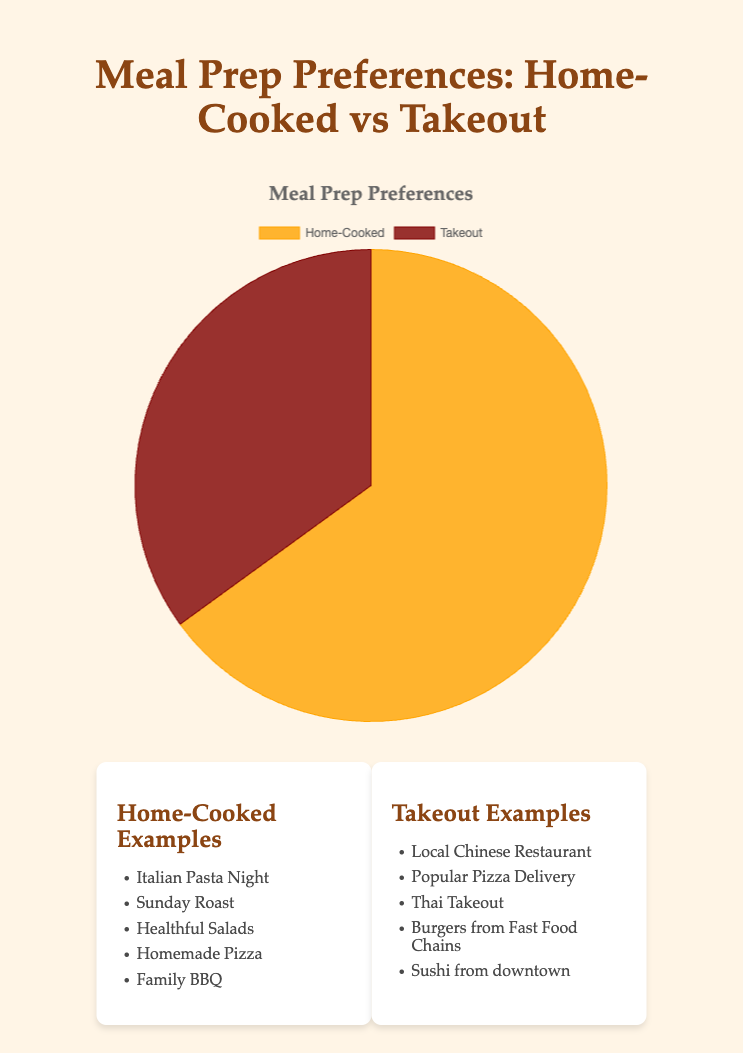what percentage of people prefer home-cooked meals? The pie chart shows two data points: one with the label "Home-Cooked" at 65% and another with "Takeout" at 35%. Simply look for the "Home-Cooked" label and read the percentage next to it.
Answer: 65% which preference is more popular, home-cooked or takeout? The chart visually shows two sections with different sizes. The part labeled "Home-Cooked" covers a larger area (65%) compared to "Takeout" (35%). So, home-cooked is more popular.
Answer: Home-cooked how much larger is the proportion of home-cooked meals compared to takeout meals? First identify the percentage for home-cooked (65%) and takeout (35%). Subtract the percentage of takeout from home-cooked: 65 - 35 = 30.
Answer: 30% what percentage of people prefer takeout meals? The chart shows a part labeled "Takeout" with a percentage value of 35%. Simply read the percentage next to "Takeout".
Answer: 35% if 200 people were surveyed, how many of them would prefer home-cooked meals? Use the percentage for home-cooked (65%) and multiply it by the total survey count (200). (65/100) * 200 = 130.
Answer: 130 if you combine the percentages of home-cooked and takeout preferences, what do you get? Add the percentages of home-cooked (65%) and takeout (35%). 65 + 35 = 100.
Answer: 100% what color represents home-cooked meals on the chart? Look for the section labeled "Home-Cooked" and its corresponding color, which is visually shown as an orange-like shade.
Answer: Orange how many percentage points more do people prefer home-cooked meals over takeout? The pie chart shows 65% for home-cooked and 35% for takeout. Subtract the takeout percentage from home-cooked: 65 - 35 = 30.
Answer: 30 which category has more distinct examples, home-cooked or takeout? Count the examples listed under each category. Home-cooked has 5 examples: Italian Pasta Night, Sunday Roast, Healthful Salads, Homemade Pizza, Family BBQ. Takeout also has 5 examples: Local Chinese Restaurant, Popular Pizza Delivery, Thai Takeout, Burgers from Fast Food Chains, Sushi from downtown.
Answer: Equal 